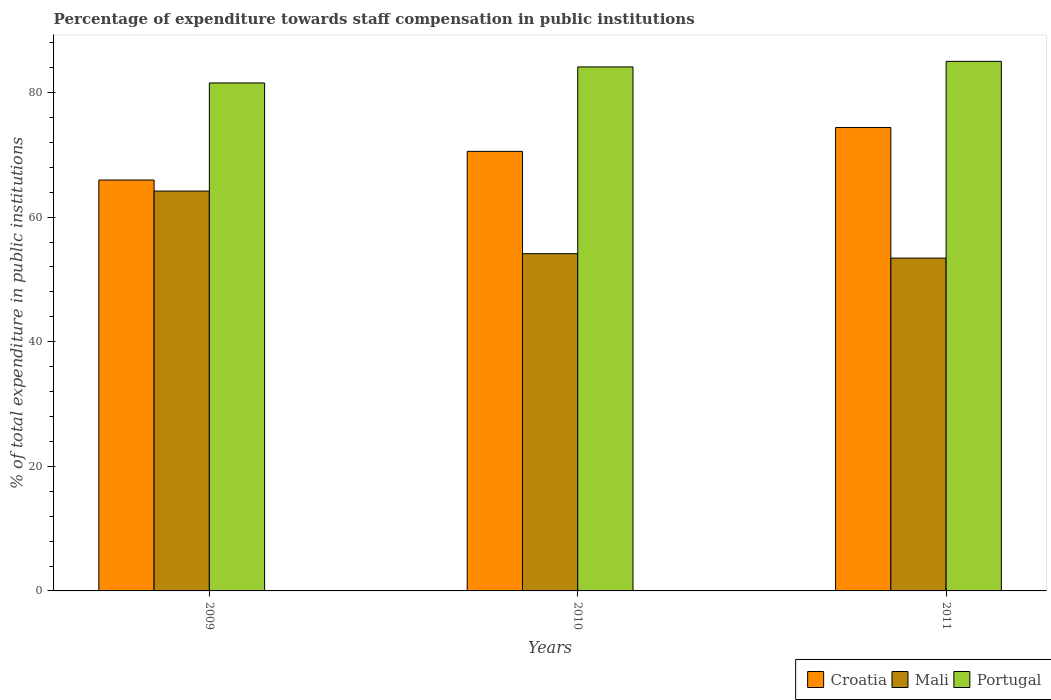How many groups of bars are there?
Your response must be concise. 3. Are the number of bars per tick equal to the number of legend labels?
Provide a short and direct response. Yes. How many bars are there on the 3rd tick from the left?
Your answer should be very brief. 3. How many bars are there on the 2nd tick from the right?
Offer a very short reply. 3. What is the percentage of expenditure towards staff compensation in Mali in 2009?
Give a very brief answer. 64.19. Across all years, what is the maximum percentage of expenditure towards staff compensation in Croatia?
Ensure brevity in your answer.  74.38. Across all years, what is the minimum percentage of expenditure towards staff compensation in Croatia?
Give a very brief answer. 65.95. In which year was the percentage of expenditure towards staff compensation in Portugal minimum?
Offer a very short reply. 2009. What is the total percentage of expenditure towards staff compensation in Portugal in the graph?
Your answer should be compact. 250.65. What is the difference between the percentage of expenditure towards staff compensation in Portugal in 2009 and that in 2011?
Provide a short and direct response. -3.47. What is the difference between the percentage of expenditure towards staff compensation in Croatia in 2011 and the percentage of expenditure towards staff compensation in Mali in 2009?
Offer a terse response. 10.19. What is the average percentage of expenditure towards staff compensation in Croatia per year?
Give a very brief answer. 70.3. In the year 2010, what is the difference between the percentage of expenditure towards staff compensation in Croatia and percentage of expenditure towards staff compensation in Mali?
Your response must be concise. 16.42. In how many years, is the percentage of expenditure towards staff compensation in Mali greater than 8 %?
Your answer should be compact. 3. What is the ratio of the percentage of expenditure towards staff compensation in Croatia in 2009 to that in 2011?
Provide a succinct answer. 0.89. Is the difference between the percentage of expenditure towards staff compensation in Croatia in 2009 and 2010 greater than the difference between the percentage of expenditure towards staff compensation in Mali in 2009 and 2010?
Provide a succinct answer. No. What is the difference between the highest and the second highest percentage of expenditure towards staff compensation in Mali?
Offer a very short reply. 10.05. What is the difference between the highest and the lowest percentage of expenditure towards staff compensation in Mali?
Provide a succinct answer. 10.76. Is the sum of the percentage of expenditure towards staff compensation in Mali in 2009 and 2010 greater than the maximum percentage of expenditure towards staff compensation in Portugal across all years?
Provide a short and direct response. Yes. What does the 1st bar from the left in 2011 represents?
Provide a succinct answer. Croatia. What does the 3rd bar from the right in 2009 represents?
Your response must be concise. Croatia. How many bars are there?
Offer a very short reply. 9. Are the values on the major ticks of Y-axis written in scientific E-notation?
Your response must be concise. No. Does the graph contain grids?
Provide a short and direct response. No. What is the title of the graph?
Make the answer very short. Percentage of expenditure towards staff compensation in public institutions. What is the label or title of the Y-axis?
Your answer should be very brief. % of total expenditure in public institutions. What is the % of total expenditure in public institutions in Croatia in 2009?
Provide a succinct answer. 65.95. What is the % of total expenditure in public institutions in Mali in 2009?
Your response must be concise. 64.19. What is the % of total expenditure in public institutions of Portugal in 2009?
Give a very brief answer. 81.54. What is the % of total expenditure in public institutions in Croatia in 2010?
Offer a very short reply. 70.56. What is the % of total expenditure in public institutions of Mali in 2010?
Keep it short and to the point. 54.13. What is the % of total expenditure in public institutions of Portugal in 2010?
Provide a short and direct response. 84.11. What is the % of total expenditure in public institutions in Croatia in 2011?
Offer a terse response. 74.38. What is the % of total expenditure in public institutions in Mali in 2011?
Ensure brevity in your answer.  53.42. What is the % of total expenditure in public institutions of Portugal in 2011?
Your answer should be compact. 85. Across all years, what is the maximum % of total expenditure in public institutions of Croatia?
Your answer should be very brief. 74.38. Across all years, what is the maximum % of total expenditure in public institutions of Mali?
Keep it short and to the point. 64.19. Across all years, what is the maximum % of total expenditure in public institutions in Portugal?
Give a very brief answer. 85. Across all years, what is the minimum % of total expenditure in public institutions in Croatia?
Give a very brief answer. 65.95. Across all years, what is the minimum % of total expenditure in public institutions of Mali?
Provide a short and direct response. 53.42. Across all years, what is the minimum % of total expenditure in public institutions of Portugal?
Your response must be concise. 81.54. What is the total % of total expenditure in public institutions in Croatia in the graph?
Offer a very short reply. 210.89. What is the total % of total expenditure in public institutions of Mali in the graph?
Offer a very short reply. 171.74. What is the total % of total expenditure in public institutions of Portugal in the graph?
Keep it short and to the point. 250.65. What is the difference between the % of total expenditure in public institutions in Croatia in 2009 and that in 2010?
Offer a terse response. -4.6. What is the difference between the % of total expenditure in public institutions in Mali in 2009 and that in 2010?
Provide a short and direct response. 10.05. What is the difference between the % of total expenditure in public institutions of Portugal in 2009 and that in 2010?
Ensure brevity in your answer.  -2.57. What is the difference between the % of total expenditure in public institutions of Croatia in 2009 and that in 2011?
Offer a terse response. -8.43. What is the difference between the % of total expenditure in public institutions of Mali in 2009 and that in 2011?
Provide a succinct answer. 10.76. What is the difference between the % of total expenditure in public institutions in Portugal in 2009 and that in 2011?
Your response must be concise. -3.47. What is the difference between the % of total expenditure in public institutions in Croatia in 2010 and that in 2011?
Provide a short and direct response. -3.82. What is the difference between the % of total expenditure in public institutions in Mali in 2010 and that in 2011?
Provide a short and direct response. 0.71. What is the difference between the % of total expenditure in public institutions of Portugal in 2010 and that in 2011?
Keep it short and to the point. -0.89. What is the difference between the % of total expenditure in public institutions in Croatia in 2009 and the % of total expenditure in public institutions in Mali in 2010?
Your answer should be compact. 11.82. What is the difference between the % of total expenditure in public institutions of Croatia in 2009 and the % of total expenditure in public institutions of Portugal in 2010?
Provide a succinct answer. -18.16. What is the difference between the % of total expenditure in public institutions of Mali in 2009 and the % of total expenditure in public institutions of Portugal in 2010?
Ensure brevity in your answer.  -19.92. What is the difference between the % of total expenditure in public institutions in Croatia in 2009 and the % of total expenditure in public institutions in Mali in 2011?
Provide a short and direct response. 12.53. What is the difference between the % of total expenditure in public institutions in Croatia in 2009 and the % of total expenditure in public institutions in Portugal in 2011?
Offer a very short reply. -19.05. What is the difference between the % of total expenditure in public institutions of Mali in 2009 and the % of total expenditure in public institutions of Portugal in 2011?
Provide a short and direct response. -20.82. What is the difference between the % of total expenditure in public institutions in Croatia in 2010 and the % of total expenditure in public institutions in Mali in 2011?
Your answer should be very brief. 17.13. What is the difference between the % of total expenditure in public institutions in Croatia in 2010 and the % of total expenditure in public institutions in Portugal in 2011?
Your answer should be compact. -14.45. What is the difference between the % of total expenditure in public institutions in Mali in 2010 and the % of total expenditure in public institutions in Portugal in 2011?
Your answer should be compact. -30.87. What is the average % of total expenditure in public institutions of Croatia per year?
Give a very brief answer. 70.3. What is the average % of total expenditure in public institutions in Mali per year?
Keep it short and to the point. 57.25. What is the average % of total expenditure in public institutions of Portugal per year?
Your response must be concise. 83.55. In the year 2009, what is the difference between the % of total expenditure in public institutions of Croatia and % of total expenditure in public institutions of Mali?
Offer a terse response. 1.77. In the year 2009, what is the difference between the % of total expenditure in public institutions of Croatia and % of total expenditure in public institutions of Portugal?
Your answer should be very brief. -15.58. In the year 2009, what is the difference between the % of total expenditure in public institutions in Mali and % of total expenditure in public institutions in Portugal?
Your answer should be compact. -17.35. In the year 2010, what is the difference between the % of total expenditure in public institutions in Croatia and % of total expenditure in public institutions in Mali?
Offer a very short reply. 16.42. In the year 2010, what is the difference between the % of total expenditure in public institutions of Croatia and % of total expenditure in public institutions of Portugal?
Give a very brief answer. -13.55. In the year 2010, what is the difference between the % of total expenditure in public institutions in Mali and % of total expenditure in public institutions in Portugal?
Your answer should be very brief. -29.98. In the year 2011, what is the difference between the % of total expenditure in public institutions of Croatia and % of total expenditure in public institutions of Mali?
Your answer should be very brief. 20.96. In the year 2011, what is the difference between the % of total expenditure in public institutions of Croatia and % of total expenditure in public institutions of Portugal?
Offer a very short reply. -10.62. In the year 2011, what is the difference between the % of total expenditure in public institutions of Mali and % of total expenditure in public institutions of Portugal?
Offer a very short reply. -31.58. What is the ratio of the % of total expenditure in public institutions of Croatia in 2009 to that in 2010?
Your answer should be very brief. 0.93. What is the ratio of the % of total expenditure in public institutions in Mali in 2009 to that in 2010?
Your answer should be compact. 1.19. What is the ratio of the % of total expenditure in public institutions of Portugal in 2009 to that in 2010?
Give a very brief answer. 0.97. What is the ratio of the % of total expenditure in public institutions in Croatia in 2009 to that in 2011?
Your answer should be compact. 0.89. What is the ratio of the % of total expenditure in public institutions of Mali in 2009 to that in 2011?
Offer a terse response. 1.2. What is the ratio of the % of total expenditure in public institutions of Portugal in 2009 to that in 2011?
Provide a short and direct response. 0.96. What is the ratio of the % of total expenditure in public institutions in Croatia in 2010 to that in 2011?
Ensure brevity in your answer.  0.95. What is the ratio of the % of total expenditure in public institutions in Mali in 2010 to that in 2011?
Provide a succinct answer. 1.01. What is the difference between the highest and the second highest % of total expenditure in public institutions of Croatia?
Your response must be concise. 3.82. What is the difference between the highest and the second highest % of total expenditure in public institutions of Mali?
Make the answer very short. 10.05. What is the difference between the highest and the second highest % of total expenditure in public institutions in Portugal?
Provide a succinct answer. 0.89. What is the difference between the highest and the lowest % of total expenditure in public institutions of Croatia?
Provide a succinct answer. 8.43. What is the difference between the highest and the lowest % of total expenditure in public institutions in Mali?
Your answer should be compact. 10.76. What is the difference between the highest and the lowest % of total expenditure in public institutions of Portugal?
Keep it short and to the point. 3.47. 